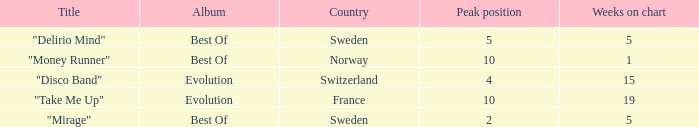What is the title of the single with the peak position of 10 and weeks on chart is less than 19? "Money Runner". 